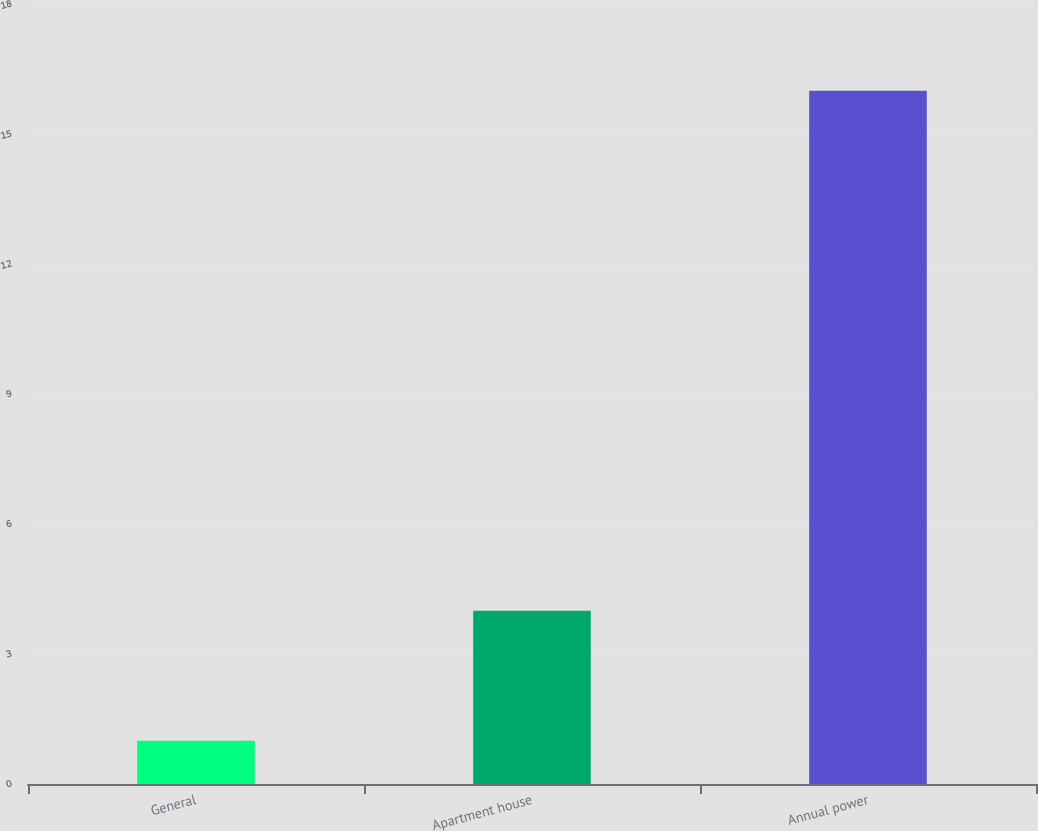Convert chart. <chart><loc_0><loc_0><loc_500><loc_500><bar_chart><fcel>General<fcel>Apartment house<fcel>Annual power<nl><fcel>1<fcel>4<fcel>16<nl></chart> 